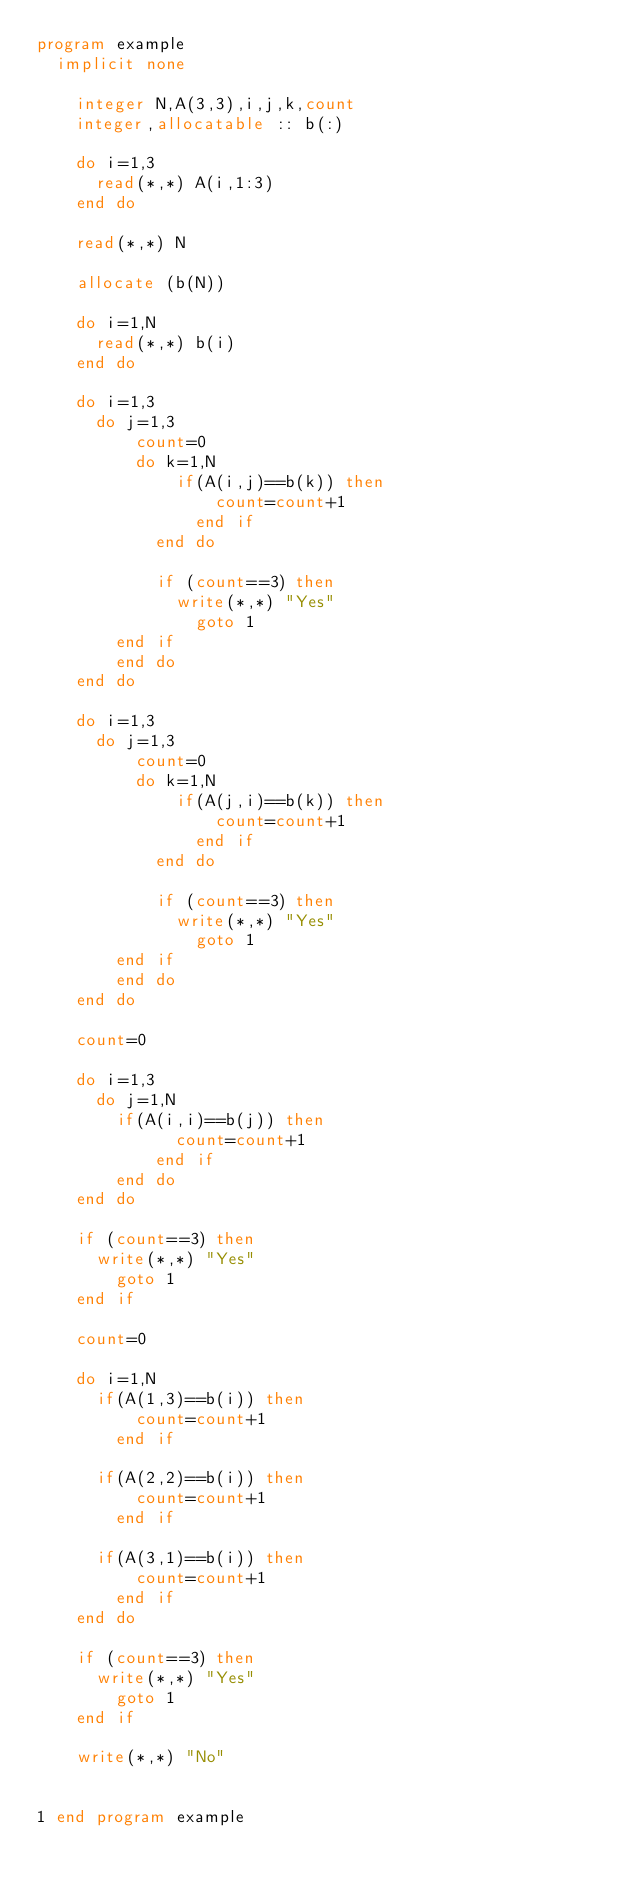<code> <loc_0><loc_0><loc_500><loc_500><_FORTRAN_>program example
	implicit none
    
    integer N,A(3,3),i,j,k,count
    integer,allocatable :: b(:)
    
    do i=1,3
    	read(*,*) A(i,1:3)
    end do
    
    read(*,*) N
    
    allocate (b(N))
    
    do i=1,N
    	read(*,*) b(i)
    end do
    
    do i=1,3
    	do j=1,3
        	count=0
        	do k=1,N
            	if(A(i,j)==b(k)) then
                	count=count+1
                end if
            end do
            
            if (count==3) then
            	write(*,*) "Yes"
                goto 1
    		end if
        end do
    end do

    do i=1,3
    	do j=1,3
        	count=0
        	do k=1,N
            	if(A(j,i)==b(k)) then
                	count=count+1
                end if
            end do
            
            if (count==3) then
            	write(*,*) "Yes"
                goto 1
    		end if
        end do
    end do
    
    count=0
    
    do i=1,3
    	do j=1,N
    		if(A(i,i)==b(j)) then
            	count=count+1
            end if
        end do
    end do
    
    if (count==3) then
    	write(*,*) "Yes"
        goto 1
    end if
    
    count=0
    
    do i=1,N
    	if(A(1,3)==b(i)) then
        	count=count+1
        end if

    	if(A(2,2)==b(i)) then
        	count=count+1
        end if

    	if(A(3,1)==b(i)) then
        	count=count+1
        end if
    end do
    
    if (count==3) then
    	write(*,*) "Yes"
        goto 1
    end if
    
    write(*,*) "No"
    
    
1 end program example</code> 